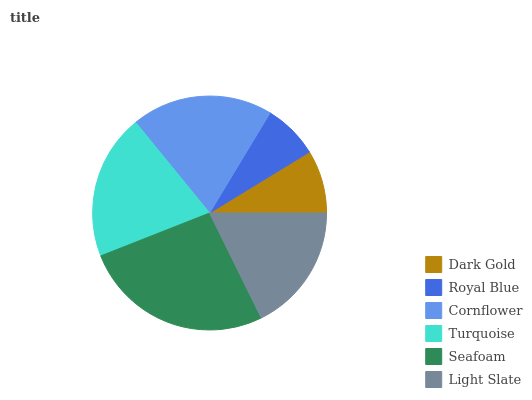Is Royal Blue the minimum?
Answer yes or no. Yes. Is Seafoam the maximum?
Answer yes or no. Yes. Is Cornflower the minimum?
Answer yes or no. No. Is Cornflower the maximum?
Answer yes or no. No. Is Cornflower greater than Royal Blue?
Answer yes or no. Yes. Is Royal Blue less than Cornflower?
Answer yes or no. Yes. Is Royal Blue greater than Cornflower?
Answer yes or no. No. Is Cornflower less than Royal Blue?
Answer yes or no. No. Is Cornflower the high median?
Answer yes or no. Yes. Is Light Slate the low median?
Answer yes or no. Yes. Is Seafoam the high median?
Answer yes or no. No. Is Turquoise the low median?
Answer yes or no. No. 